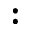Convert formula to latex. <formula><loc_0><loc_0><loc_500><loc_500>\colon</formula> 